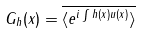Convert formula to latex. <formula><loc_0><loc_0><loc_500><loc_500>G _ { h } ( x ) = \overline { \langle e ^ { i \int h ( x ) u ( x ) } \rangle }</formula> 